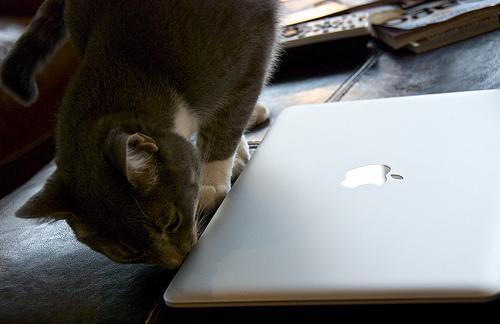How many computers?
Give a very brief answer. 1. How many black laptops are there?
Give a very brief answer. 0. 